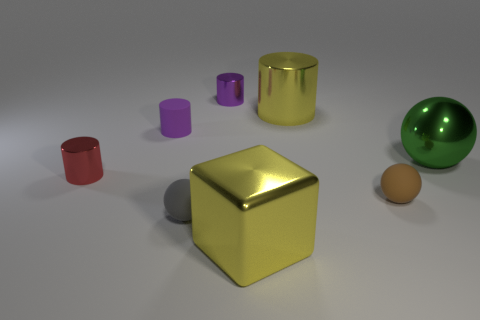Subtract 1 cylinders. How many cylinders are left? 3 Add 1 tiny green rubber balls. How many objects exist? 9 Subtract all balls. How many objects are left? 5 Add 2 yellow cylinders. How many yellow cylinders are left? 3 Add 5 small brown spheres. How many small brown spheres exist? 6 Subtract 1 yellow cubes. How many objects are left? 7 Subtract all big cyan cylinders. Subtract all big yellow metallic objects. How many objects are left? 6 